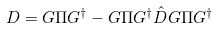<formula> <loc_0><loc_0><loc_500><loc_500>D = G \Pi G ^ { \dagger } - G \Pi G ^ { \dagger } \hat { D } G \Pi G ^ { \dagger }</formula> 